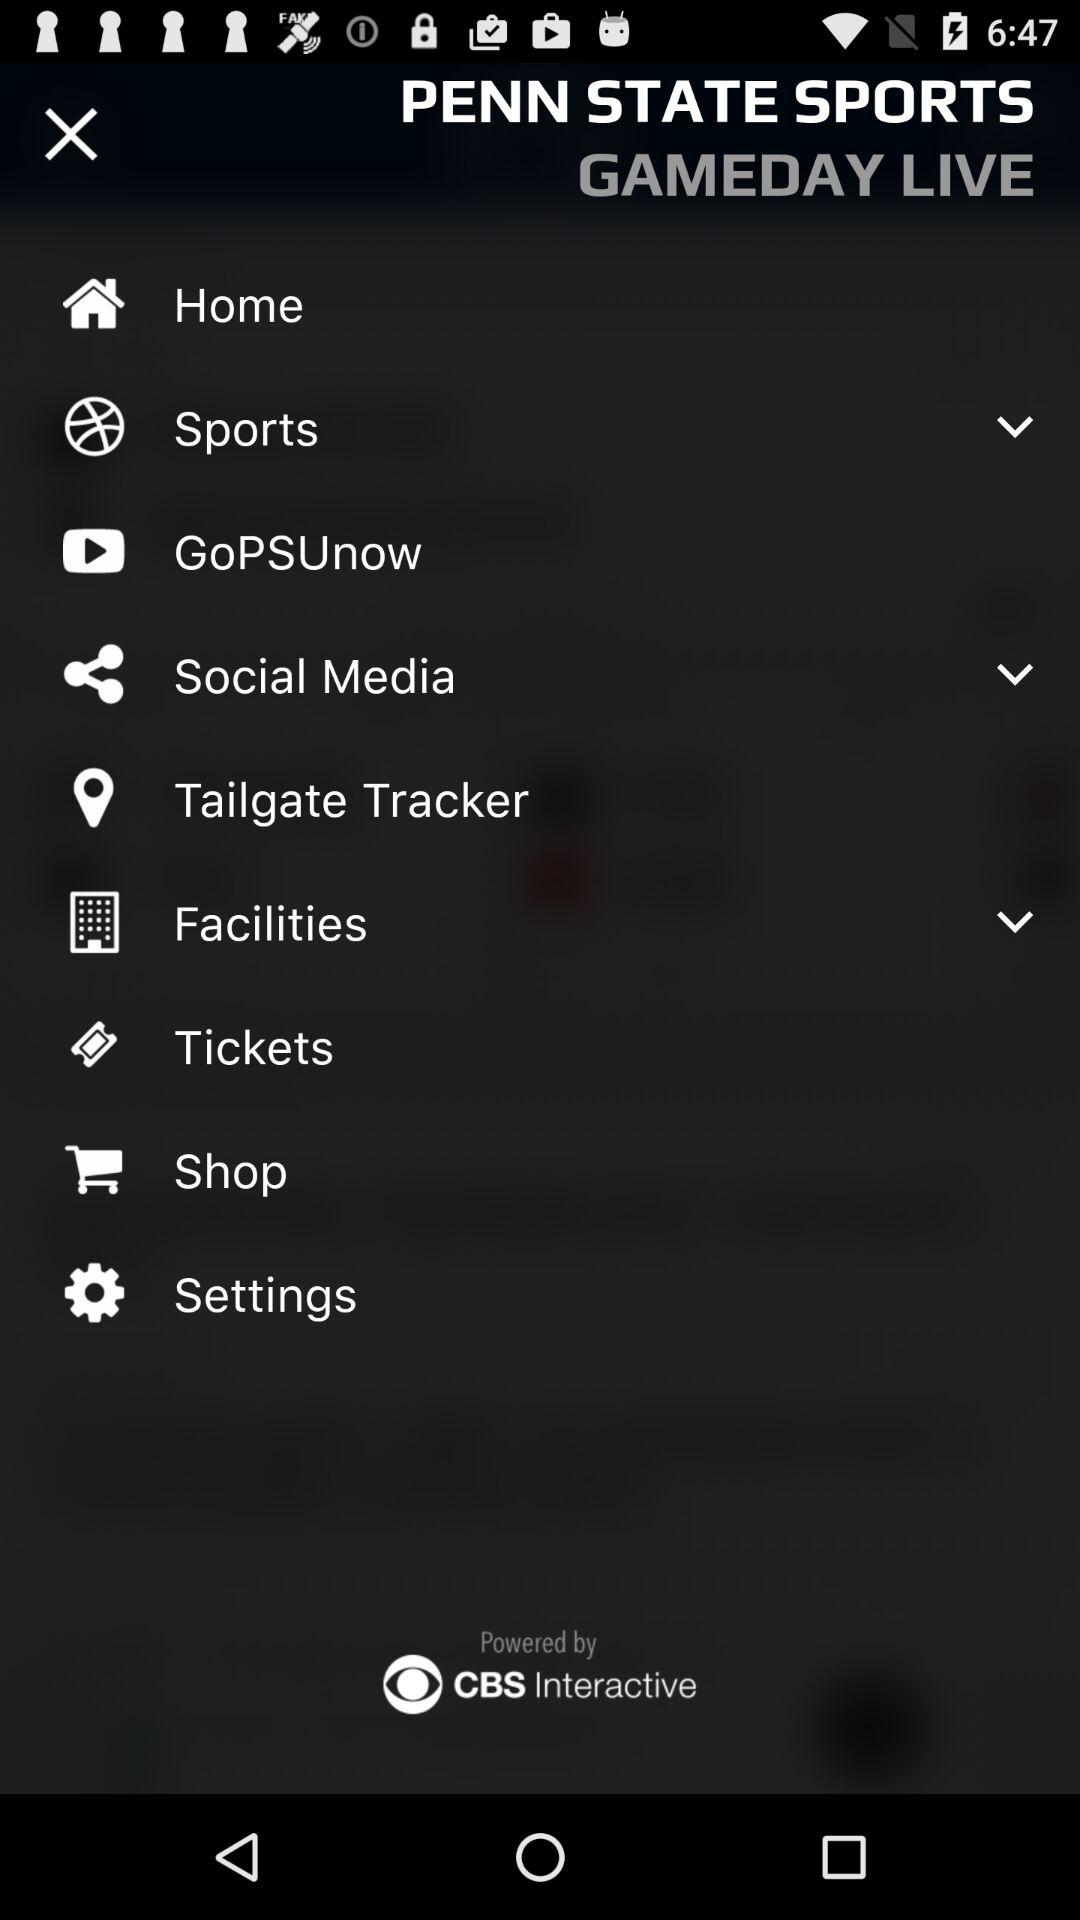What is the app title? The app title is "PENN STATE SPORTS GAMEDAY LIVE". 